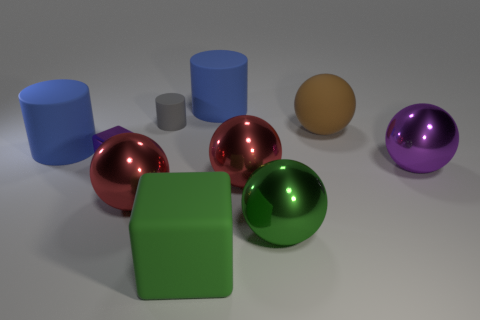Subtract all gray cylinders. How many cylinders are left? 2 Subtract all green cubes. How many cubes are left? 1 Subtract all blue cylinders. How many green blocks are left? 1 Subtract 0 green cylinders. How many objects are left? 10 Subtract all blocks. How many objects are left? 8 Subtract 2 cylinders. How many cylinders are left? 1 Subtract all purple cylinders. Subtract all blue balls. How many cylinders are left? 3 Subtract all gray rubber cubes. Subtract all rubber cubes. How many objects are left? 9 Add 4 big purple metallic objects. How many big purple metallic objects are left? 5 Add 9 yellow matte blocks. How many yellow matte blocks exist? 9 